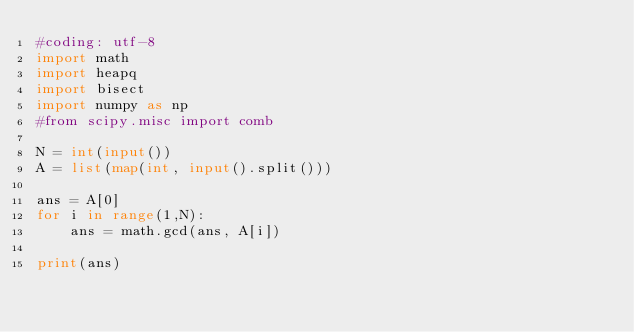<code> <loc_0><loc_0><loc_500><loc_500><_Python_>#coding: utf-8
import math
import heapq
import bisect
import numpy as np
#from scipy.misc import comb

N = int(input())
A = list(map(int, input().split()))

ans = A[0]
for i in range(1,N):
    ans = math.gcd(ans, A[i])

print(ans)</code> 